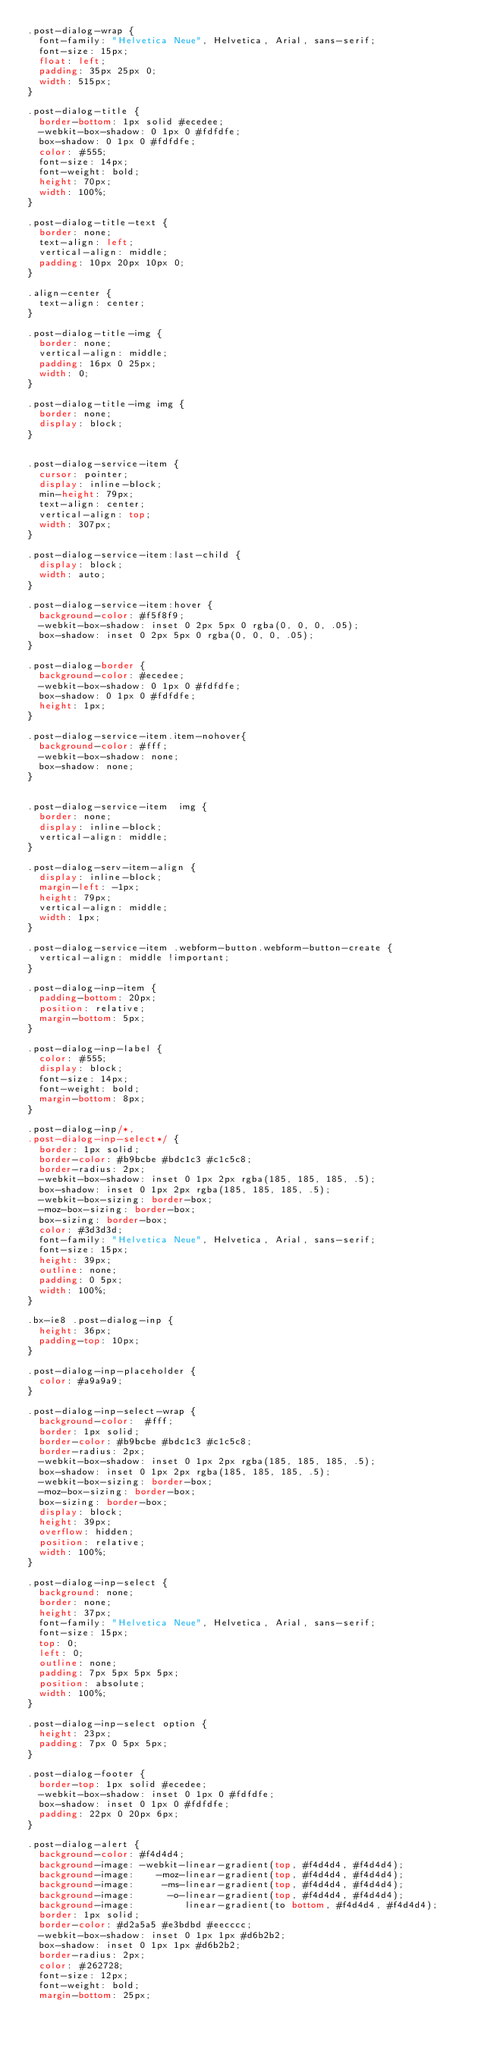Convert code to text. <code><loc_0><loc_0><loc_500><loc_500><_CSS_>.post-dialog-wrap {
	font-family: "Helvetica Neue", Helvetica, Arial, sans-serif;
	font-size: 15px;
	float: left;
	padding: 35px 25px 0;
	width: 515px;
}

.post-dialog-title {
	border-bottom: 1px solid #ecedee;
	-webkit-box-shadow: 0 1px 0 #fdfdfe;
	box-shadow: 0 1px 0 #fdfdfe;
	color: #555;
	font-size: 14px;
	font-weight: bold;
	height: 70px;
	width: 100%;
}

.post-dialog-title-text {
	border: none;
	text-align: left;
	vertical-align: middle;
	padding: 10px 20px 10px 0;
}

.align-center {
	text-align: center;
}

.post-dialog-title-img {
	border: none;
	vertical-align: middle;
	padding: 16px 0 25px;
	width: 0;
}

.post-dialog-title-img img {
	border: none;
	display: block;
}


.post-dialog-service-item {
	cursor: pointer;
	display: inline-block;
	min-height: 79px;
	text-align: center;
	vertical-align: top;
	width: 307px;
}

.post-dialog-service-item:last-child {
	display: block;
	width: auto;
}

.post-dialog-service-item:hover {
	background-color: #f5f8f9;
	-webkit-box-shadow: inset 0 2px 5px 0 rgba(0, 0, 0, .05);
	box-shadow: inset 0 2px 5px 0 rgba(0, 0, 0, .05);
}

.post-dialog-border {
	background-color: #ecedee;
	-webkit-box-shadow: 0 1px 0 #fdfdfe;
	box-shadow: 0 1px 0 #fdfdfe;
	height: 1px;
}

.post-dialog-service-item.item-nohover{
	background-color: #fff;
	-webkit-box-shadow: none;
	box-shadow: none;
}


.post-dialog-service-item  img {
	border: none;
	display: inline-block;
	vertical-align: middle;
}

.post-dialog-serv-item-align {
	display: inline-block;
	margin-left: -1px;
	height: 79px;
	vertical-align: middle;
	width: 1px;
}

.post-dialog-service-item .webform-button.webform-button-create {
	vertical-align: middle !important;
}

.post-dialog-inp-item {
	padding-bottom: 20px;
	position: relative;
	margin-bottom: 5px;
}

.post-dialog-inp-label {
	color: #555;
	display: block;
	font-size: 14px;
	font-weight: bold;
	margin-bottom: 8px;
}

.post-dialog-inp/*,
.post-dialog-inp-select*/ {
	border: 1px solid;
	border-color: #b9bcbe #bdc1c3 #c1c5c8;
	border-radius: 2px;
	-webkit-box-shadow: inset 0 1px 2px rgba(185, 185, 185, .5);
	box-shadow: inset 0 1px 2px rgba(185, 185, 185, .5);
	-webkit-box-sizing: border-box;
	-moz-box-sizing: border-box;
	box-sizing: border-box;
	color: #3d3d3d;
	font-family: "Helvetica Neue", Helvetica, Arial, sans-serif;
	font-size: 15px;
	height: 39px;
	outline: none;
	padding: 0 5px;
	width: 100%;
}

.bx-ie8 .post-dialog-inp {
	height: 36px;
	padding-top: 10px;
}

.post-dialog-inp-placeholder {
	color: #a9a9a9;
}

.post-dialog-inp-select-wrap {
	background-color:  #fff;
	border: 1px solid;
	border-color: #b9bcbe #bdc1c3 #c1c5c8;
	border-radius: 2px;
	-webkit-box-shadow: inset 0 1px 2px rgba(185, 185, 185, .5);
	box-shadow: inset 0 1px 2px rgba(185, 185, 185, .5);
	-webkit-box-sizing: border-box;
	-moz-box-sizing: border-box;
	box-sizing: border-box;
	display: block;
	height: 39px;
	overflow: hidden;
	position: relative;
	width: 100%;
}

.post-dialog-inp-select {
	background: none;
	border: none;
	height: 37px;
	font-family: "Helvetica Neue", Helvetica, Arial, sans-serif;
	font-size: 15px;
	top: 0;
	left: 0;
	outline: none;
	padding: 7px 5px 5px 5px;
	position: absolute;
	width: 100%;
}

.post-dialog-inp-select option {
	height: 23px;
	padding: 7px 0 5px 5px;
}

.post-dialog-footer {
	border-top: 1px solid #ecedee;
	-webkit-box-shadow: inset 0 1px 0 #fdfdfe;
	box-shadow: inset 0 1px 0 #fdfdfe;
	padding: 22px 0 20px 6px;
}

.post-dialog-alert {
	background-color: #f4d4d4;
	background-image: -webkit-linear-gradient(top, #f4d4d4, #f4d4d4);
	background-image:    -moz-linear-gradient(top, #f4d4d4, #f4d4d4);
	background-image:     -ms-linear-gradient(top, #f4d4d4, #f4d4d4);
	background-image:      -o-linear-gradient(top, #f4d4d4, #f4d4d4);
	background-image:         linear-gradient(to bottom, #f4d4d4, #f4d4d4);
	border: 1px solid;
	border-color: #d2a5a5 #e3bdbd #eecccc;
	-webkit-box-shadow: inset 0 1px 1px #d6b2b2;
	box-shadow: inset 0 1px 1px #d6b2b2;
	border-radius: 2px;
	color: #262728;
	font-size: 12px;
	font-weight: bold;
	margin-bottom: 25px;</code> 